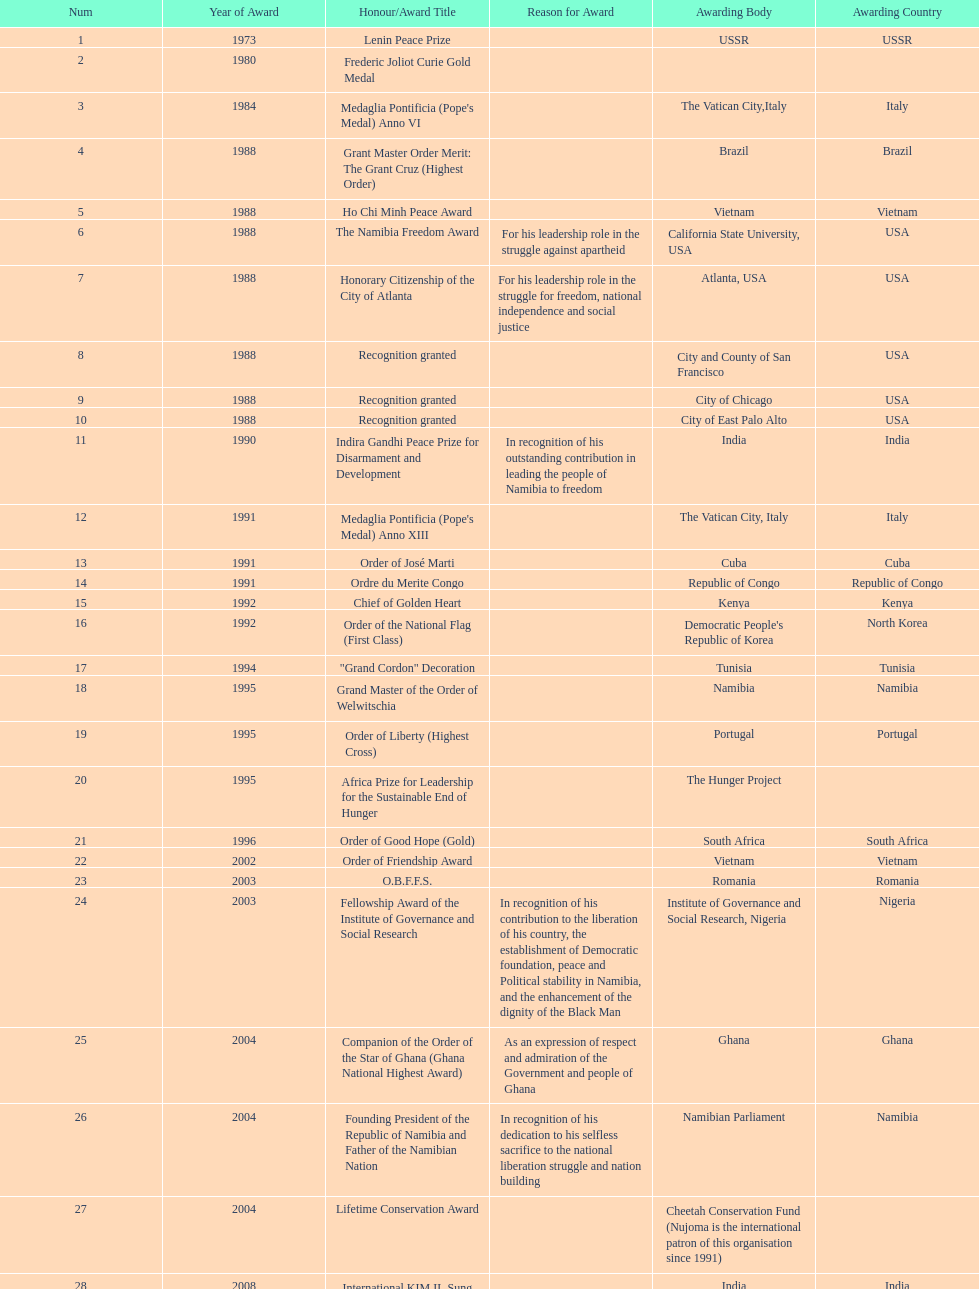Did nujoma win the o.b.f.f.s. award in romania or ghana? Romania. 